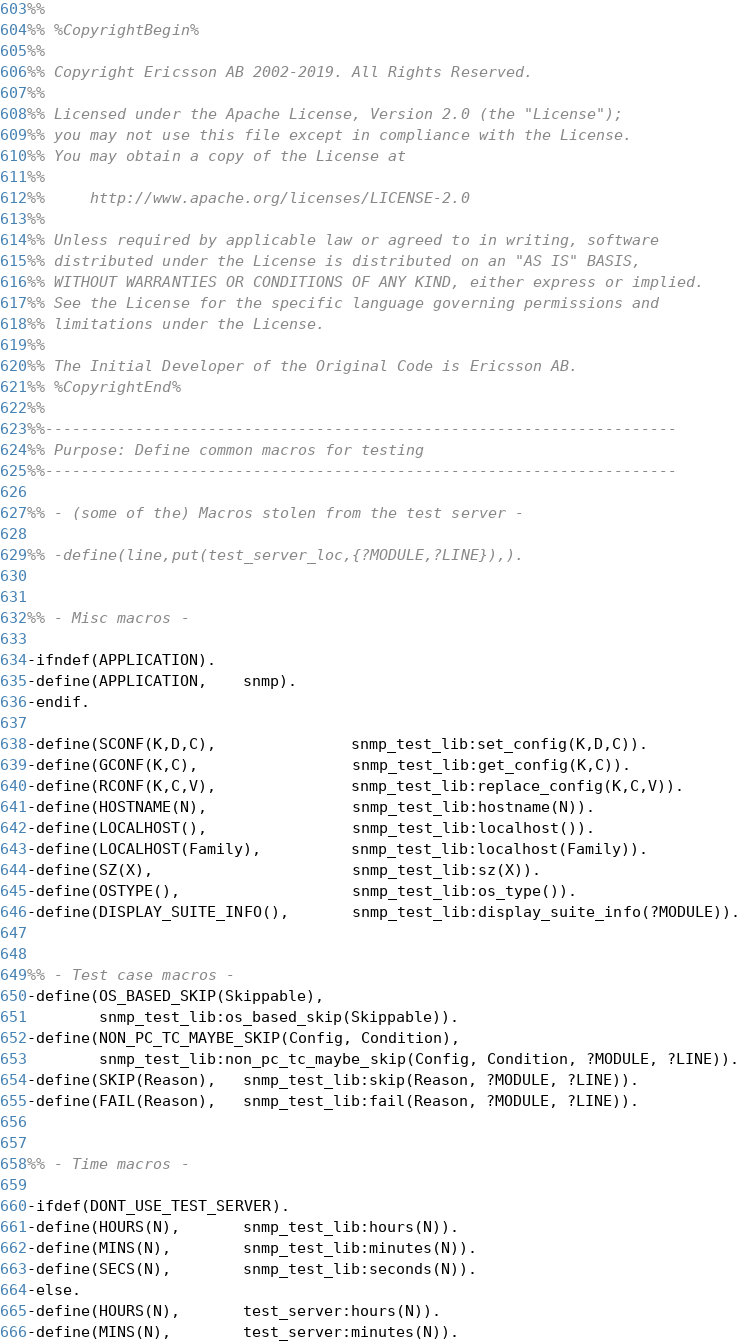Convert code to text. <code><loc_0><loc_0><loc_500><loc_500><_Erlang_>%%
%% %CopyrightBegin%
%%
%% Copyright Ericsson AB 2002-2019. All Rights Reserved.
%%
%% Licensed under the Apache License, Version 2.0 (the "License");
%% you may not use this file except in compliance with the License.
%% You may obtain a copy of the License at
%%
%%     http://www.apache.org/licenses/LICENSE-2.0
%%
%% Unless required by applicable law or agreed to in writing, software
%% distributed under the License is distributed on an "AS IS" BASIS,
%% WITHOUT WARRANTIES OR CONDITIONS OF ANY KIND, either express or implied.
%% See the License for the specific language governing permissions and
%% limitations under the License.
%%
%% The Initial Developer of the Original Code is Ericsson AB.
%% %CopyrightEnd%
%%
%%----------------------------------------------------------------------
%% Purpose: Define common macros for testing
%%----------------------------------------------------------------------

%% - (some of the) Macros stolen from the test server -

%% -define(line,put(test_server_loc,{?MODULE,?LINE}),).


%% - Misc macros -

-ifndef(APPLICATION).
-define(APPLICATION,    snmp).
-endif.

-define(SCONF(K,D,C),               snmp_test_lib:set_config(K,D,C)).
-define(GCONF(K,C),                 snmp_test_lib:get_config(K,C)).
-define(RCONF(K,C,V),               snmp_test_lib:replace_config(K,C,V)).
-define(HOSTNAME(N),                snmp_test_lib:hostname(N)).
-define(LOCALHOST(),                snmp_test_lib:localhost()).
-define(LOCALHOST(Family),          snmp_test_lib:localhost(Family)).
-define(SZ(X),                      snmp_test_lib:sz(X)).
-define(OSTYPE(),                   snmp_test_lib:os_type()).
-define(DISPLAY_SUITE_INFO(),       snmp_test_lib:display_suite_info(?MODULE)).


%% - Test case macros - 
-define(OS_BASED_SKIP(Skippable),
        snmp_test_lib:os_based_skip(Skippable)).
-define(NON_PC_TC_MAYBE_SKIP(Config, Condition),
        snmp_test_lib:non_pc_tc_maybe_skip(Config, Condition, ?MODULE, ?LINE)).
-define(SKIP(Reason),   snmp_test_lib:skip(Reason, ?MODULE, ?LINE)).
-define(FAIL(Reason),   snmp_test_lib:fail(Reason, ?MODULE, ?LINE)).


%% - Time macros -

-ifdef(DONT_USE_TEST_SERVER).
-define(HOURS(N),       snmp_test_lib:hours(N)).
-define(MINS(N),        snmp_test_lib:minutes(N)).
-define(SECS(N),        snmp_test_lib:seconds(N)).
-else.
-define(HOURS(N),       test_server:hours(N)).
-define(MINS(N),        test_server:minutes(N)).</code> 